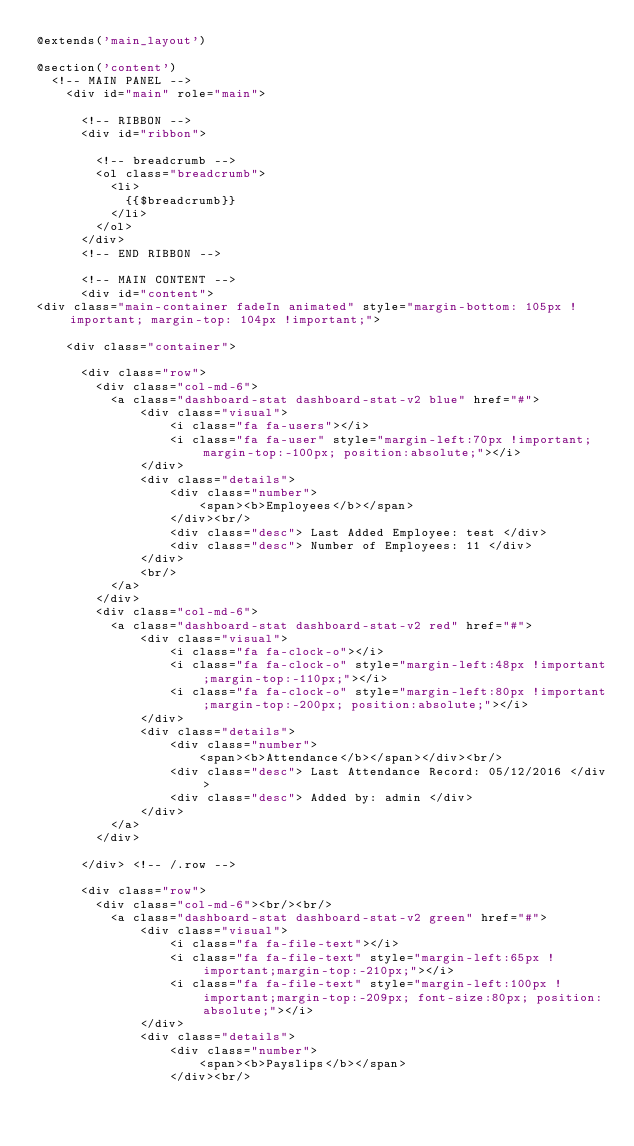<code> <loc_0><loc_0><loc_500><loc_500><_PHP_>@extends('main_layout')

@section('content')
  <!-- MAIN PANEL -->
    <div id="main" role="main">

      <!-- RIBBON -->
      <div id="ribbon">        

        <!-- breadcrumb -->
        <ol class="breadcrumb">
          <li>
            {{$breadcrumb}}
          </li>
        </ol>        
      </div>
      <!-- END RIBBON -->

      <!-- MAIN CONTENT -->
      <div id="content">
<div class="main-container fadeIn animated" style="margin-bottom: 105px !important; margin-top: 104px !important;">

    <div class="container">

      <div class="row">
        <div class="col-md-6">
          <a class="dashboard-stat dashboard-stat-v2 blue" href="#">
              <div class="visual">
                  <i class="fa fa-users"></i>
                  <i class="fa fa-user" style="margin-left:70px !important;margin-top:-100px; position:absolute;"></i>
              </div>
              <div class="details">
                  <div class="number">
                      <span><b>Employees</b></span>
                  </div><br/>
                  <div class="desc"> Last Added Employee: test </div>
                  <div class="desc"> Number of Employees: 11 </div>
              </div>
              <br/>
          </a>          
        </div>
        <div class="col-md-6">
          <a class="dashboard-stat dashboard-stat-v2 red" href="#">
              <div class="visual">
                  <i class="fa fa-clock-o"></i>
                  <i class="fa fa-clock-o" style="margin-left:48px !important;margin-top:-110px;"></i>
                  <i class="fa fa-clock-o" style="margin-left:80px !important;margin-top:-200px; position:absolute;"></i>
              </div>
              <div class="details">
                  <div class="number">
                      <span><b>Attendance</b></span></div><br/>
                  <div class="desc"> Last Attendance Record: 05/12/2016 </div>
                  <div class="desc"> Added by: admin </div>
              </div>
          </a>
        </div>

      </div> <!-- /.row -->

      <div class="row">
        <div class="col-md-6"><br/><br/>
          <a class="dashboard-stat dashboard-stat-v2 green" href="#">
              <div class="visual">
                  <i class="fa fa-file-text"></i>
                  <i class="fa fa-file-text" style="margin-left:65px !important;margin-top:-210px;"></i>
                  <i class="fa fa-file-text" style="margin-left:100px !important;margin-top:-209px; font-size:80px; position:absolute;"></i>
              </div>
              <div class="details">
                  <div class="number">
                      <span><b>Payslips</b></span>
                  </div><br/></code> 